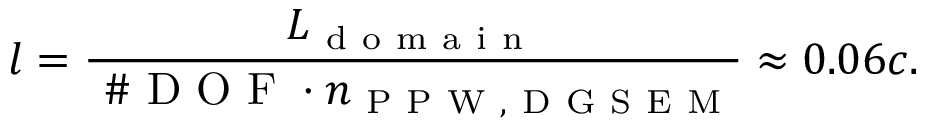Convert formula to latex. <formula><loc_0><loc_0><loc_500><loc_500>l = \frac { L _ { d o m a i n } } { \# D O F \cdot n _ { P P W , D G S E M } } \approx 0 . 0 6 c .</formula> 